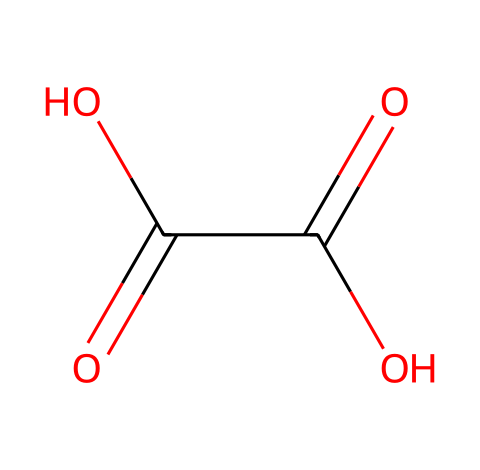What is the common name of this compound? The SMILES representation corresponds to the structure of oxalic acid, which is a known organic compound.
Answer: oxalic acid How many carboxylic acid groups are present in this structure? By analyzing the structure, we see there are two -COOH (carboxylic acid) groups represented in the formula.
Answer: 2 What is the total number of carbon atoms in this molecule? There is a count of two carbon (C) atoms visible in the structure, as indicated by the two -COOH functional groups connected to them.
Answer: 2 What is the oxidation state of each carbon atom in this molecule? The oxidation state can be determined as follows: each carbon in the carboxylic acid group is generally considered to have a +3 oxidation state since they are bonded to oxygen, one of which is double-bonded.
Answer: +3 What type of acid is oxalic acid classified as? Based on its structure, oxalic acid contains carboxyl groups, classifying it as a dicarboxylic acid.
Answer: dicarboxylic acid Which functional groups are responsible for the acidic properties of oxalic acid? The carboxylic acid groups (-COOH) in the structure are responsible for the acidic properties, as they can donate protons (H+ ions).
Answer: carboxylic acid groups How many total hydrogen atoms are in this molecule? By examining the structure, each -COOH contributes one hydrogen atom and there are no additional hydrogens on the carbons, leading to a total of two hydrogen atoms.
Answer: 2 